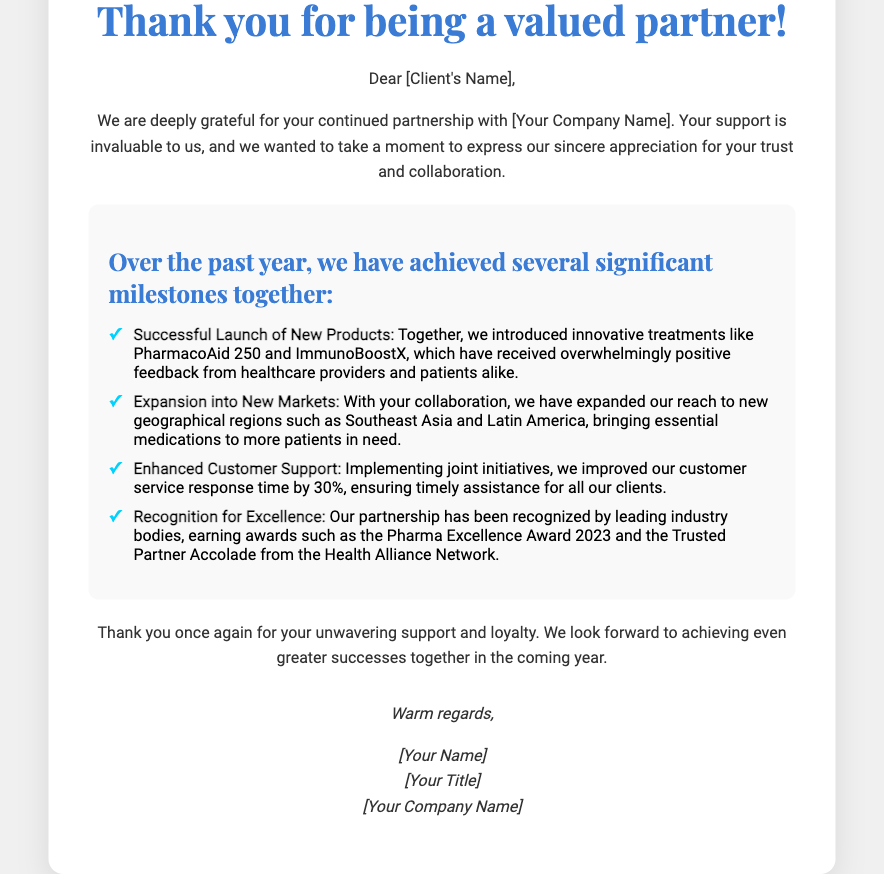What is the primary theme of the card? The primary theme of the card is expressing gratitude for the client's partnership and support.
Answer: Client Appreciation Who is the intended recipient of the card? The recipient is identified in the greeting as "[Client's Name]."
Answer: [Client's Name] What is one of the new products launched together? The document states that PharmacoAid 250 was a successful new product launched.
Answer: PharmacoAid 250 By what percentage was the customer service response time improved? The improvement in customer service response time is noted as 30%.
Answer: 30% Which award is mentioned in relation to the partnership? The card mentions the Pharma Excellence Award 2023 as an accolade received.
Answer: Pharma Excellence Award 2023 What is the concluding sentiment expressed in the card? The card concludes with a sentiment of looking forward to greater successes together.
Answer: Greater successes together How is the design of the card described? The card is described as having a sophisticated design with a sleek appearance and textured finish.
Answer: Sophisticated design What color scheme is used for the card’s title? The color scheme for the title includes shades of blue, specifically #3a7bd5.
Answer: Shades of blue What type of initiatives improved customer support? The document mentions "joint initiatives" as the type of actions taken to enhance customer support.
Answer: Joint initiatives 